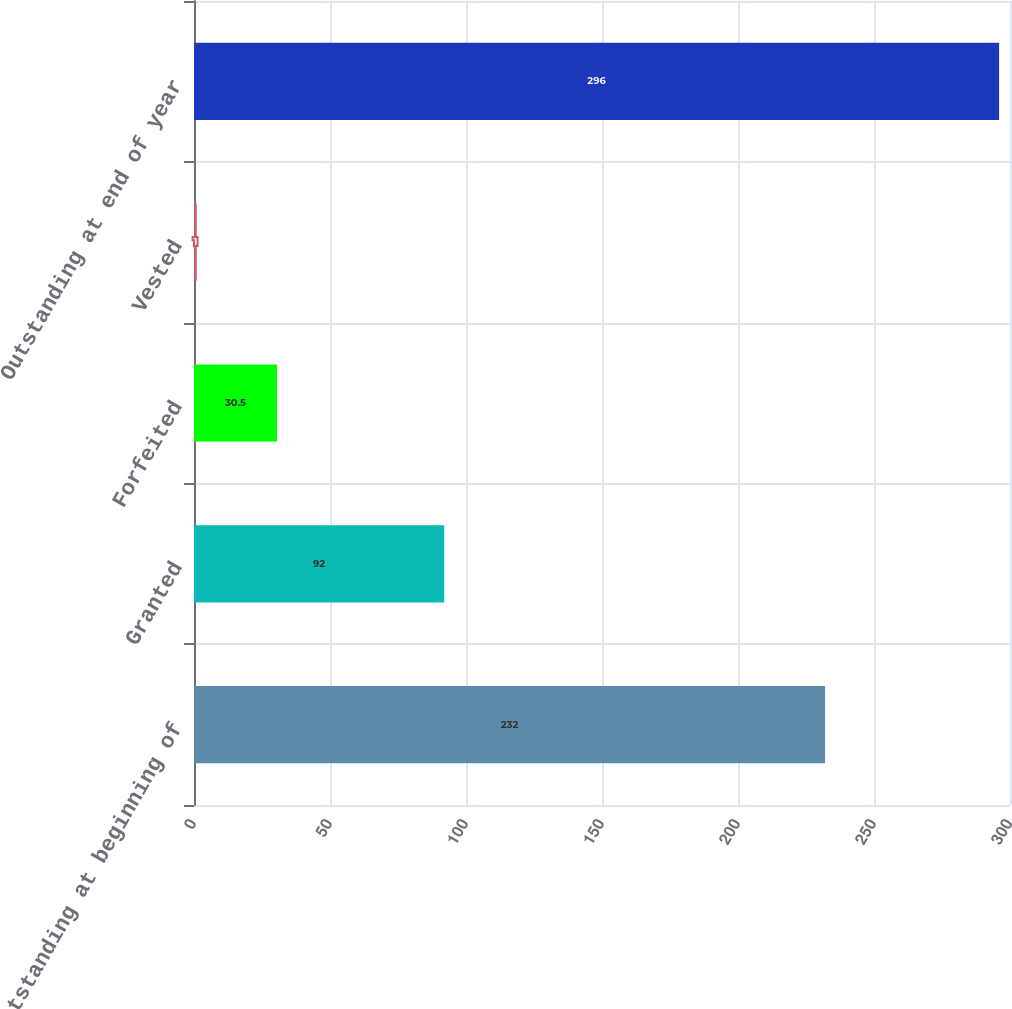<chart> <loc_0><loc_0><loc_500><loc_500><bar_chart><fcel>Outstanding at beginning of<fcel>Granted<fcel>Forfeited<fcel>Vested<fcel>Outstanding at end of year<nl><fcel>232<fcel>92<fcel>30.5<fcel>1<fcel>296<nl></chart> 